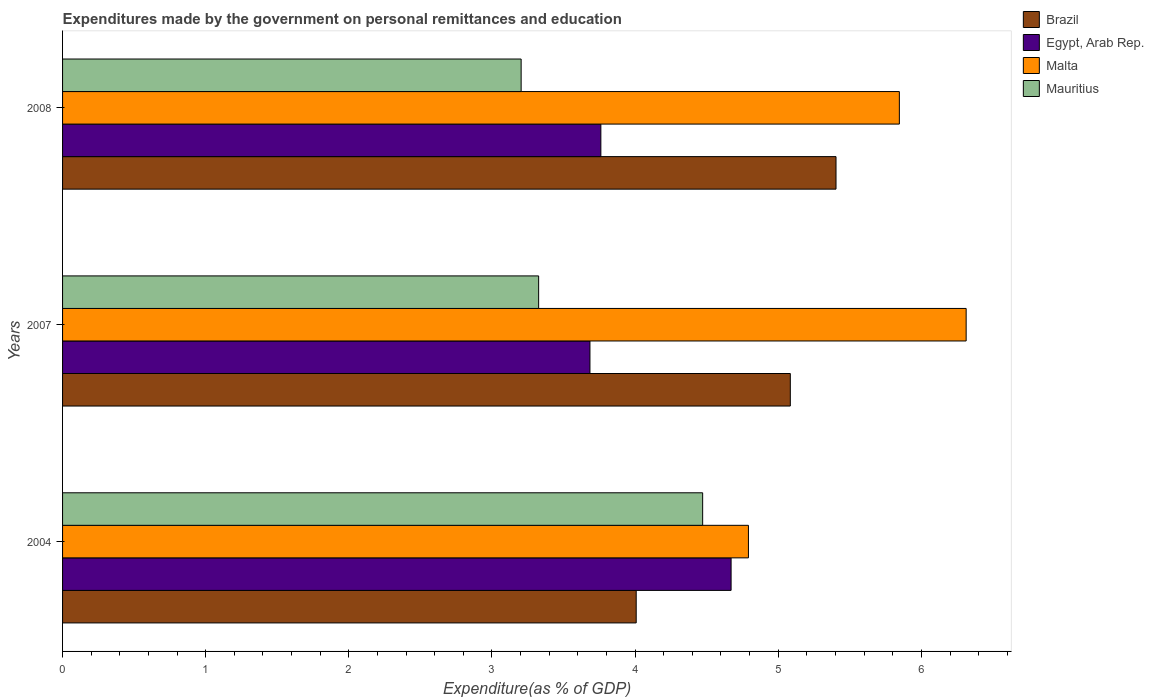How many different coloured bars are there?
Your response must be concise. 4. Are the number of bars per tick equal to the number of legend labels?
Keep it short and to the point. Yes. How many bars are there on the 2nd tick from the bottom?
Offer a terse response. 4. What is the expenditures made by the government on personal remittances and education in Egypt, Arab Rep. in 2008?
Your response must be concise. 3.76. Across all years, what is the maximum expenditures made by the government on personal remittances and education in Egypt, Arab Rep.?
Your answer should be very brief. 4.67. Across all years, what is the minimum expenditures made by the government on personal remittances and education in Brazil?
Make the answer very short. 4.01. In which year was the expenditures made by the government on personal remittances and education in Egypt, Arab Rep. maximum?
Ensure brevity in your answer.  2004. In which year was the expenditures made by the government on personal remittances and education in Egypt, Arab Rep. minimum?
Keep it short and to the point. 2007. What is the total expenditures made by the government on personal remittances and education in Egypt, Arab Rep. in the graph?
Ensure brevity in your answer.  12.12. What is the difference between the expenditures made by the government on personal remittances and education in Egypt, Arab Rep. in 2007 and that in 2008?
Give a very brief answer. -0.08. What is the difference between the expenditures made by the government on personal remittances and education in Brazil in 2004 and the expenditures made by the government on personal remittances and education in Mauritius in 2007?
Your response must be concise. 0.68. What is the average expenditures made by the government on personal remittances and education in Malta per year?
Give a very brief answer. 5.65. In the year 2008, what is the difference between the expenditures made by the government on personal remittances and education in Egypt, Arab Rep. and expenditures made by the government on personal remittances and education in Mauritius?
Give a very brief answer. 0.56. In how many years, is the expenditures made by the government on personal remittances and education in Egypt, Arab Rep. greater than 0.8 %?
Your response must be concise. 3. What is the ratio of the expenditures made by the government on personal remittances and education in Brazil in 2004 to that in 2007?
Offer a terse response. 0.79. Is the difference between the expenditures made by the government on personal remittances and education in Egypt, Arab Rep. in 2004 and 2007 greater than the difference between the expenditures made by the government on personal remittances and education in Mauritius in 2004 and 2007?
Offer a terse response. No. What is the difference between the highest and the second highest expenditures made by the government on personal remittances and education in Malta?
Provide a short and direct response. 0.47. What is the difference between the highest and the lowest expenditures made by the government on personal remittances and education in Brazil?
Make the answer very short. 1.4. In how many years, is the expenditures made by the government on personal remittances and education in Brazil greater than the average expenditures made by the government on personal remittances and education in Brazil taken over all years?
Your response must be concise. 2. Is the sum of the expenditures made by the government on personal remittances and education in Brazil in 2004 and 2008 greater than the maximum expenditures made by the government on personal remittances and education in Malta across all years?
Give a very brief answer. Yes. What does the 1st bar from the bottom in 2004 represents?
Your response must be concise. Brazil. Are all the bars in the graph horizontal?
Make the answer very short. Yes. What is the difference between two consecutive major ticks on the X-axis?
Keep it short and to the point. 1. Are the values on the major ticks of X-axis written in scientific E-notation?
Offer a terse response. No. Does the graph contain grids?
Your response must be concise. No. Where does the legend appear in the graph?
Your response must be concise. Top right. How many legend labels are there?
Offer a terse response. 4. How are the legend labels stacked?
Keep it short and to the point. Vertical. What is the title of the graph?
Provide a short and direct response. Expenditures made by the government on personal remittances and education. What is the label or title of the X-axis?
Ensure brevity in your answer.  Expenditure(as % of GDP). What is the Expenditure(as % of GDP) of Brazil in 2004?
Keep it short and to the point. 4.01. What is the Expenditure(as % of GDP) of Egypt, Arab Rep. in 2004?
Offer a very short reply. 4.67. What is the Expenditure(as % of GDP) in Malta in 2004?
Provide a short and direct response. 4.79. What is the Expenditure(as % of GDP) of Mauritius in 2004?
Give a very brief answer. 4.47. What is the Expenditure(as % of GDP) of Brazil in 2007?
Ensure brevity in your answer.  5.08. What is the Expenditure(as % of GDP) of Egypt, Arab Rep. in 2007?
Ensure brevity in your answer.  3.68. What is the Expenditure(as % of GDP) of Malta in 2007?
Offer a terse response. 6.31. What is the Expenditure(as % of GDP) in Mauritius in 2007?
Keep it short and to the point. 3.33. What is the Expenditure(as % of GDP) in Brazil in 2008?
Ensure brevity in your answer.  5.4. What is the Expenditure(as % of GDP) in Egypt, Arab Rep. in 2008?
Keep it short and to the point. 3.76. What is the Expenditure(as % of GDP) in Malta in 2008?
Your response must be concise. 5.85. What is the Expenditure(as % of GDP) in Mauritius in 2008?
Provide a short and direct response. 3.2. Across all years, what is the maximum Expenditure(as % of GDP) of Brazil?
Ensure brevity in your answer.  5.4. Across all years, what is the maximum Expenditure(as % of GDP) of Egypt, Arab Rep.?
Offer a very short reply. 4.67. Across all years, what is the maximum Expenditure(as % of GDP) in Malta?
Your answer should be compact. 6.31. Across all years, what is the maximum Expenditure(as % of GDP) in Mauritius?
Provide a short and direct response. 4.47. Across all years, what is the minimum Expenditure(as % of GDP) in Brazil?
Your response must be concise. 4.01. Across all years, what is the minimum Expenditure(as % of GDP) of Egypt, Arab Rep.?
Your answer should be very brief. 3.68. Across all years, what is the minimum Expenditure(as % of GDP) in Malta?
Provide a short and direct response. 4.79. Across all years, what is the minimum Expenditure(as % of GDP) of Mauritius?
Keep it short and to the point. 3.2. What is the total Expenditure(as % of GDP) in Brazil in the graph?
Your answer should be very brief. 14.5. What is the total Expenditure(as % of GDP) of Egypt, Arab Rep. in the graph?
Provide a short and direct response. 12.12. What is the total Expenditure(as % of GDP) of Malta in the graph?
Your response must be concise. 16.95. What is the total Expenditure(as % of GDP) in Mauritius in the graph?
Provide a succinct answer. 11. What is the difference between the Expenditure(as % of GDP) in Brazil in 2004 and that in 2007?
Provide a short and direct response. -1.08. What is the difference between the Expenditure(as % of GDP) of Egypt, Arab Rep. in 2004 and that in 2007?
Ensure brevity in your answer.  0.99. What is the difference between the Expenditure(as % of GDP) of Malta in 2004 and that in 2007?
Your answer should be very brief. -1.52. What is the difference between the Expenditure(as % of GDP) in Mauritius in 2004 and that in 2007?
Offer a terse response. 1.15. What is the difference between the Expenditure(as % of GDP) of Brazil in 2004 and that in 2008?
Offer a very short reply. -1.4. What is the difference between the Expenditure(as % of GDP) in Egypt, Arab Rep. in 2004 and that in 2008?
Provide a short and direct response. 0.91. What is the difference between the Expenditure(as % of GDP) of Malta in 2004 and that in 2008?
Provide a succinct answer. -1.05. What is the difference between the Expenditure(as % of GDP) in Mauritius in 2004 and that in 2008?
Make the answer very short. 1.27. What is the difference between the Expenditure(as % of GDP) of Brazil in 2007 and that in 2008?
Provide a short and direct response. -0.32. What is the difference between the Expenditure(as % of GDP) in Egypt, Arab Rep. in 2007 and that in 2008?
Offer a very short reply. -0.08. What is the difference between the Expenditure(as % of GDP) in Malta in 2007 and that in 2008?
Ensure brevity in your answer.  0.47. What is the difference between the Expenditure(as % of GDP) in Mauritius in 2007 and that in 2008?
Your answer should be compact. 0.12. What is the difference between the Expenditure(as % of GDP) of Brazil in 2004 and the Expenditure(as % of GDP) of Egypt, Arab Rep. in 2007?
Your answer should be compact. 0.32. What is the difference between the Expenditure(as % of GDP) of Brazil in 2004 and the Expenditure(as % of GDP) of Malta in 2007?
Keep it short and to the point. -2.31. What is the difference between the Expenditure(as % of GDP) of Brazil in 2004 and the Expenditure(as % of GDP) of Mauritius in 2007?
Your answer should be very brief. 0.68. What is the difference between the Expenditure(as % of GDP) in Egypt, Arab Rep. in 2004 and the Expenditure(as % of GDP) in Malta in 2007?
Offer a very short reply. -1.64. What is the difference between the Expenditure(as % of GDP) of Egypt, Arab Rep. in 2004 and the Expenditure(as % of GDP) of Mauritius in 2007?
Provide a short and direct response. 1.34. What is the difference between the Expenditure(as % of GDP) of Malta in 2004 and the Expenditure(as % of GDP) of Mauritius in 2007?
Your answer should be very brief. 1.47. What is the difference between the Expenditure(as % of GDP) in Brazil in 2004 and the Expenditure(as % of GDP) in Egypt, Arab Rep. in 2008?
Ensure brevity in your answer.  0.25. What is the difference between the Expenditure(as % of GDP) of Brazil in 2004 and the Expenditure(as % of GDP) of Malta in 2008?
Offer a very short reply. -1.84. What is the difference between the Expenditure(as % of GDP) in Brazil in 2004 and the Expenditure(as % of GDP) in Mauritius in 2008?
Make the answer very short. 0.8. What is the difference between the Expenditure(as % of GDP) in Egypt, Arab Rep. in 2004 and the Expenditure(as % of GDP) in Malta in 2008?
Your answer should be compact. -1.18. What is the difference between the Expenditure(as % of GDP) in Egypt, Arab Rep. in 2004 and the Expenditure(as % of GDP) in Mauritius in 2008?
Offer a terse response. 1.47. What is the difference between the Expenditure(as % of GDP) in Malta in 2004 and the Expenditure(as % of GDP) in Mauritius in 2008?
Provide a succinct answer. 1.59. What is the difference between the Expenditure(as % of GDP) of Brazil in 2007 and the Expenditure(as % of GDP) of Egypt, Arab Rep. in 2008?
Provide a short and direct response. 1.32. What is the difference between the Expenditure(as % of GDP) in Brazil in 2007 and the Expenditure(as % of GDP) in Malta in 2008?
Provide a succinct answer. -0.76. What is the difference between the Expenditure(as % of GDP) of Brazil in 2007 and the Expenditure(as % of GDP) of Mauritius in 2008?
Your answer should be compact. 1.88. What is the difference between the Expenditure(as % of GDP) of Egypt, Arab Rep. in 2007 and the Expenditure(as % of GDP) of Malta in 2008?
Your answer should be very brief. -2.16. What is the difference between the Expenditure(as % of GDP) in Egypt, Arab Rep. in 2007 and the Expenditure(as % of GDP) in Mauritius in 2008?
Provide a short and direct response. 0.48. What is the difference between the Expenditure(as % of GDP) in Malta in 2007 and the Expenditure(as % of GDP) in Mauritius in 2008?
Offer a very short reply. 3.11. What is the average Expenditure(as % of GDP) in Brazil per year?
Your answer should be compact. 4.83. What is the average Expenditure(as % of GDP) of Egypt, Arab Rep. per year?
Your response must be concise. 4.04. What is the average Expenditure(as % of GDP) in Malta per year?
Provide a succinct answer. 5.65. What is the average Expenditure(as % of GDP) of Mauritius per year?
Offer a very short reply. 3.67. In the year 2004, what is the difference between the Expenditure(as % of GDP) of Brazil and Expenditure(as % of GDP) of Egypt, Arab Rep.?
Your response must be concise. -0.66. In the year 2004, what is the difference between the Expenditure(as % of GDP) in Brazil and Expenditure(as % of GDP) in Malta?
Offer a terse response. -0.78. In the year 2004, what is the difference between the Expenditure(as % of GDP) of Brazil and Expenditure(as % of GDP) of Mauritius?
Your response must be concise. -0.46. In the year 2004, what is the difference between the Expenditure(as % of GDP) of Egypt, Arab Rep. and Expenditure(as % of GDP) of Malta?
Your answer should be very brief. -0.12. In the year 2004, what is the difference between the Expenditure(as % of GDP) in Egypt, Arab Rep. and Expenditure(as % of GDP) in Mauritius?
Provide a succinct answer. 0.2. In the year 2004, what is the difference between the Expenditure(as % of GDP) in Malta and Expenditure(as % of GDP) in Mauritius?
Offer a terse response. 0.32. In the year 2007, what is the difference between the Expenditure(as % of GDP) in Brazil and Expenditure(as % of GDP) in Egypt, Arab Rep.?
Ensure brevity in your answer.  1.4. In the year 2007, what is the difference between the Expenditure(as % of GDP) of Brazil and Expenditure(as % of GDP) of Malta?
Give a very brief answer. -1.23. In the year 2007, what is the difference between the Expenditure(as % of GDP) in Brazil and Expenditure(as % of GDP) in Mauritius?
Provide a succinct answer. 1.76. In the year 2007, what is the difference between the Expenditure(as % of GDP) in Egypt, Arab Rep. and Expenditure(as % of GDP) in Malta?
Give a very brief answer. -2.63. In the year 2007, what is the difference between the Expenditure(as % of GDP) of Egypt, Arab Rep. and Expenditure(as % of GDP) of Mauritius?
Your answer should be compact. 0.36. In the year 2007, what is the difference between the Expenditure(as % of GDP) in Malta and Expenditure(as % of GDP) in Mauritius?
Offer a terse response. 2.99. In the year 2008, what is the difference between the Expenditure(as % of GDP) of Brazil and Expenditure(as % of GDP) of Egypt, Arab Rep.?
Offer a very short reply. 1.64. In the year 2008, what is the difference between the Expenditure(as % of GDP) in Brazil and Expenditure(as % of GDP) in Malta?
Offer a terse response. -0.44. In the year 2008, what is the difference between the Expenditure(as % of GDP) in Brazil and Expenditure(as % of GDP) in Mauritius?
Offer a very short reply. 2.2. In the year 2008, what is the difference between the Expenditure(as % of GDP) in Egypt, Arab Rep. and Expenditure(as % of GDP) in Malta?
Give a very brief answer. -2.09. In the year 2008, what is the difference between the Expenditure(as % of GDP) of Egypt, Arab Rep. and Expenditure(as % of GDP) of Mauritius?
Provide a short and direct response. 0.56. In the year 2008, what is the difference between the Expenditure(as % of GDP) of Malta and Expenditure(as % of GDP) of Mauritius?
Your answer should be compact. 2.64. What is the ratio of the Expenditure(as % of GDP) of Brazil in 2004 to that in 2007?
Offer a terse response. 0.79. What is the ratio of the Expenditure(as % of GDP) in Egypt, Arab Rep. in 2004 to that in 2007?
Provide a succinct answer. 1.27. What is the ratio of the Expenditure(as % of GDP) of Malta in 2004 to that in 2007?
Give a very brief answer. 0.76. What is the ratio of the Expenditure(as % of GDP) of Mauritius in 2004 to that in 2007?
Make the answer very short. 1.34. What is the ratio of the Expenditure(as % of GDP) of Brazil in 2004 to that in 2008?
Your response must be concise. 0.74. What is the ratio of the Expenditure(as % of GDP) of Egypt, Arab Rep. in 2004 to that in 2008?
Your response must be concise. 1.24. What is the ratio of the Expenditure(as % of GDP) in Malta in 2004 to that in 2008?
Your response must be concise. 0.82. What is the ratio of the Expenditure(as % of GDP) in Mauritius in 2004 to that in 2008?
Your answer should be very brief. 1.4. What is the ratio of the Expenditure(as % of GDP) of Brazil in 2007 to that in 2008?
Your answer should be compact. 0.94. What is the ratio of the Expenditure(as % of GDP) of Egypt, Arab Rep. in 2007 to that in 2008?
Make the answer very short. 0.98. What is the ratio of the Expenditure(as % of GDP) in Malta in 2007 to that in 2008?
Your answer should be compact. 1.08. What is the ratio of the Expenditure(as % of GDP) in Mauritius in 2007 to that in 2008?
Provide a short and direct response. 1.04. What is the difference between the highest and the second highest Expenditure(as % of GDP) of Brazil?
Your response must be concise. 0.32. What is the difference between the highest and the second highest Expenditure(as % of GDP) of Egypt, Arab Rep.?
Provide a short and direct response. 0.91. What is the difference between the highest and the second highest Expenditure(as % of GDP) of Malta?
Your response must be concise. 0.47. What is the difference between the highest and the second highest Expenditure(as % of GDP) in Mauritius?
Your response must be concise. 1.15. What is the difference between the highest and the lowest Expenditure(as % of GDP) of Brazil?
Offer a very short reply. 1.4. What is the difference between the highest and the lowest Expenditure(as % of GDP) in Egypt, Arab Rep.?
Offer a terse response. 0.99. What is the difference between the highest and the lowest Expenditure(as % of GDP) in Malta?
Your response must be concise. 1.52. What is the difference between the highest and the lowest Expenditure(as % of GDP) in Mauritius?
Provide a short and direct response. 1.27. 